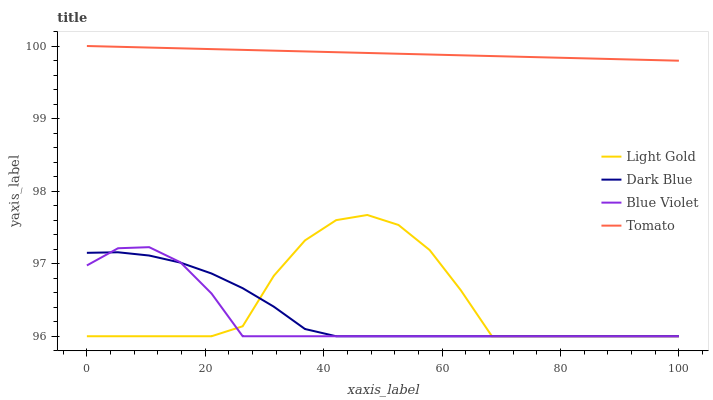Does Blue Violet have the minimum area under the curve?
Answer yes or no. Yes. Does Tomato have the maximum area under the curve?
Answer yes or no. Yes. Does Dark Blue have the minimum area under the curve?
Answer yes or no. No. Does Dark Blue have the maximum area under the curve?
Answer yes or no. No. Is Tomato the smoothest?
Answer yes or no. Yes. Is Light Gold the roughest?
Answer yes or no. Yes. Is Dark Blue the smoothest?
Answer yes or no. No. Is Dark Blue the roughest?
Answer yes or no. No. Does Dark Blue have the lowest value?
Answer yes or no. Yes. Does Tomato have the highest value?
Answer yes or no. Yes. Does Light Gold have the highest value?
Answer yes or no. No. Is Light Gold less than Tomato?
Answer yes or no. Yes. Is Tomato greater than Light Gold?
Answer yes or no. Yes. Does Dark Blue intersect Light Gold?
Answer yes or no. Yes. Is Dark Blue less than Light Gold?
Answer yes or no. No. Is Dark Blue greater than Light Gold?
Answer yes or no. No. Does Light Gold intersect Tomato?
Answer yes or no. No. 